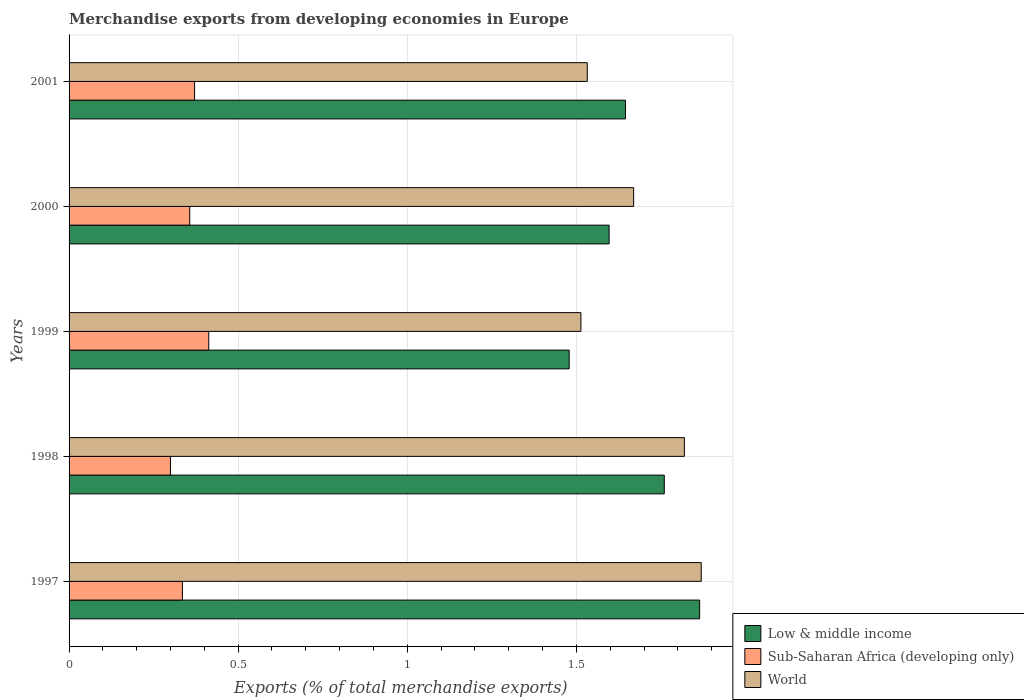Are the number of bars on each tick of the Y-axis equal?
Give a very brief answer. Yes. How many bars are there on the 3rd tick from the bottom?
Provide a short and direct response. 3. In how many cases, is the number of bars for a given year not equal to the number of legend labels?
Offer a terse response. 0. What is the percentage of total merchandise exports in Low & middle income in 1998?
Offer a very short reply. 1.76. Across all years, what is the maximum percentage of total merchandise exports in World?
Ensure brevity in your answer.  1.87. Across all years, what is the minimum percentage of total merchandise exports in Sub-Saharan Africa (developing only)?
Keep it short and to the point. 0.3. In which year was the percentage of total merchandise exports in World maximum?
Your answer should be very brief. 1997. What is the total percentage of total merchandise exports in Low & middle income in the graph?
Your answer should be compact. 8.35. What is the difference between the percentage of total merchandise exports in Sub-Saharan Africa (developing only) in 1998 and that in 1999?
Provide a short and direct response. -0.11. What is the difference between the percentage of total merchandise exports in World in 2000 and the percentage of total merchandise exports in Low & middle income in 2001?
Offer a terse response. 0.02. What is the average percentage of total merchandise exports in Sub-Saharan Africa (developing only) per year?
Offer a terse response. 0.36. In the year 2001, what is the difference between the percentage of total merchandise exports in Sub-Saharan Africa (developing only) and percentage of total merchandise exports in Low & middle income?
Keep it short and to the point. -1.27. What is the ratio of the percentage of total merchandise exports in Low & middle income in 1998 to that in 2000?
Ensure brevity in your answer.  1.1. What is the difference between the highest and the second highest percentage of total merchandise exports in World?
Keep it short and to the point. 0.05. What is the difference between the highest and the lowest percentage of total merchandise exports in Low & middle income?
Your answer should be compact. 0.39. Is the sum of the percentage of total merchandise exports in Sub-Saharan Africa (developing only) in 1998 and 1999 greater than the maximum percentage of total merchandise exports in Low & middle income across all years?
Your answer should be compact. No. What does the 2nd bar from the top in 2001 represents?
Offer a very short reply. Sub-Saharan Africa (developing only). Is it the case that in every year, the sum of the percentage of total merchandise exports in Sub-Saharan Africa (developing only) and percentage of total merchandise exports in World is greater than the percentage of total merchandise exports in Low & middle income?
Ensure brevity in your answer.  Yes. Are all the bars in the graph horizontal?
Provide a succinct answer. Yes. Are the values on the major ticks of X-axis written in scientific E-notation?
Your answer should be compact. No. What is the title of the graph?
Provide a succinct answer. Merchandise exports from developing economies in Europe. Does "Zambia" appear as one of the legend labels in the graph?
Ensure brevity in your answer.  No. What is the label or title of the X-axis?
Make the answer very short. Exports (% of total merchandise exports). What is the Exports (% of total merchandise exports) of Low & middle income in 1997?
Give a very brief answer. 1.86. What is the Exports (% of total merchandise exports) of Sub-Saharan Africa (developing only) in 1997?
Give a very brief answer. 0.34. What is the Exports (% of total merchandise exports) of World in 1997?
Keep it short and to the point. 1.87. What is the Exports (% of total merchandise exports) of Low & middle income in 1998?
Provide a succinct answer. 1.76. What is the Exports (% of total merchandise exports) in Sub-Saharan Africa (developing only) in 1998?
Your response must be concise. 0.3. What is the Exports (% of total merchandise exports) of World in 1998?
Provide a short and direct response. 1.82. What is the Exports (% of total merchandise exports) of Low & middle income in 1999?
Offer a terse response. 1.48. What is the Exports (% of total merchandise exports) in Sub-Saharan Africa (developing only) in 1999?
Provide a succinct answer. 0.41. What is the Exports (% of total merchandise exports) of World in 1999?
Give a very brief answer. 1.51. What is the Exports (% of total merchandise exports) in Low & middle income in 2000?
Provide a succinct answer. 1.6. What is the Exports (% of total merchandise exports) in Sub-Saharan Africa (developing only) in 2000?
Provide a succinct answer. 0.36. What is the Exports (% of total merchandise exports) in World in 2000?
Offer a very short reply. 1.67. What is the Exports (% of total merchandise exports) in Low & middle income in 2001?
Give a very brief answer. 1.65. What is the Exports (% of total merchandise exports) of Sub-Saharan Africa (developing only) in 2001?
Keep it short and to the point. 0.37. What is the Exports (% of total merchandise exports) in World in 2001?
Give a very brief answer. 1.53. Across all years, what is the maximum Exports (% of total merchandise exports) in Low & middle income?
Keep it short and to the point. 1.86. Across all years, what is the maximum Exports (% of total merchandise exports) of Sub-Saharan Africa (developing only)?
Your answer should be compact. 0.41. Across all years, what is the maximum Exports (% of total merchandise exports) of World?
Offer a very short reply. 1.87. Across all years, what is the minimum Exports (% of total merchandise exports) in Low & middle income?
Your answer should be compact. 1.48. Across all years, what is the minimum Exports (% of total merchandise exports) of Sub-Saharan Africa (developing only)?
Offer a very short reply. 0.3. Across all years, what is the minimum Exports (% of total merchandise exports) of World?
Offer a very short reply. 1.51. What is the total Exports (% of total merchandise exports) in Low & middle income in the graph?
Provide a short and direct response. 8.35. What is the total Exports (% of total merchandise exports) of Sub-Saharan Africa (developing only) in the graph?
Your response must be concise. 1.78. What is the total Exports (% of total merchandise exports) of World in the graph?
Ensure brevity in your answer.  8.4. What is the difference between the Exports (% of total merchandise exports) of Low & middle income in 1997 and that in 1998?
Provide a succinct answer. 0.1. What is the difference between the Exports (% of total merchandise exports) in Sub-Saharan Africa (developing only) in 1997 and that in 1998?
Your response must be concise. 0.04. What is the difference between the Exports (% of total merchandise exports) in World in 1997 and that in 1998?
Provide a succinct answer. 0.05. What is the difference between the Exports (% of total merchandise exports) in Low & middle income in 1997 and that in 1999?
Offer a very short reply. 0.39. What is the difference between the Exports (% of total merchandise exports) of Sub-Saharan Africa (developing only) in 1997 and that in 1999?
Provide a short and direct response. -0.08. What is the difference between the Exports (% of total merchandise exports) in World in 1997 and that in 1999?
Your answer should be very brief. 0.36. What is the difference between the Exports (% of total merchandise exports) of Low & middle income in 1997 and that in 2000?
Offer a very short reply. 0.27. What is the difference between the Exports (% of total merchandise exports) in Sub-Saharan Africa (developing only) in 1997 and that in 2000?
Your answer should be very brief. -0.02. What is the difference between the Exports (% of total merchandise exports) of World in 1997 and that in 2000?
Make the answer very short. 0.2. What is the difference between the Exports (% of total merchandise exports) in Low & middle income in 1997 and that in 2001?
Ensure brevity in your answer.  0.22. What is the difference between the Exports (% of total merchandise exports) in Sub-Saharan Africa (developing only) in 1997 and that in 2001?
Your response must be concise. -0.04. What is the difference between the Exports (% of total merchandise exports) in World in 1997 and that in 2001?
Make the answer very short. 0.34. What is the difference between the Exports (% of total merchandise exports) of Low & middle income in 1998 and that in 1999?
Offer a very short reply. 0.28. What is the difference between the Exports (% of total merchandise exports) of Sub-Saharan Africa (developing only) in 1998 and that in 1999?
Ensure brevity in your answer.  -0.11. What is the difference between the Exports (% of total merchandise exports) of World in 1998 and that in 1999?
Your response must be concise. 0.31. What is the difference between the Exports (% of total merchandise exports) of Low & middle income in 1998 and that in 2000?
Your answer should be very brief. 0.16. What is the difference between the Exports (% of total merchandise exports) of Sub-Saharan Africa (developing only) in 1998 and that in 2000?
Your answer should be very brief. -0.06. What is the difference between the Exports (% of total merchandise exports) of World in 1998 and that in 2000?
Provide a succinct answer. 0.15. What is the difference between the Exports (% of total merchandise exports) in Low & middle income in 1998 and that in 2001?
Offer a terse response. 0.11. What is the difference between the Exports (% of total merchandise exports) of Sub-Saharan Africa (developing only) in 1998 and that in 2001?
Give a very brief answer. -0.07. What is the difference between the Exports (% of total merchandise exports) of World in 1998 and that in 2001?
Provide a short and direct response. 0.29. What is the difference between the Exports (% of total merchandise exports) in Low & middle income in 1999 and that in 2000?
Your answer should be very brief. -0.12. What is the difference between the Exports (% of total merchandise exports) in Sub-Saharan Africa (developing only) in 1999 and that in 2000?
Provide a short and direct response. 0.06. What is the difference between the Exports (% of total merchandise exports) of World in 1999 and that in 2000?
Provide a succinct answer. -0.16. What is the difference between the Exports (% of total merchandise exports) in Low & middle income in 1999 and that in 2001?
Keep it short and to the point. -0.17. What is the difference between the Exports (% of total merchandise exports) in Sub-Saharan Africa (developing only) in 1999 and that in 2001?
Offer a very short reply. 0.04. What is the difference between the Exports (% of total merchandise exports) of World in 1999 and that in 2001?
Your answer should be very brief. -0.02. What is the difference between the Exports (% of total merchandise exports) in Low & middle income in 2000 and that in 2001?
Give a very brief answer. -0.05. What is the difference between the Exports (% of total merchandise exports) of Sub-Saharan Africa (developing only) in 2000 and that in 2001?
Your answer should be compact. -0.01. What is the difference between the Exports (% of total merchandise exports) of World in 2000 and that in 2001?
Ensure brevity in your answer.  0.14. What is the difference between the Exports (% of total merchandise exports) in Low & middle income in 1997 and the Exports (% of total merchandise exports) in Sub-Saharan Africa (developing only) in 1998?
Offer a very short reply. 1.56. What is the difference between the Exports (% of total merchandise exports) in Low & middle income in 1997 and the Exports (% of total merchandise exports) in World in 1998?
Ensure brevity in your answer.  0.05. What is the difference between the Exports (% of total merchandise exports) of Sub-Saharan Africa (developing only) in 1997 and the Exports (% of total merchandise exports) of World in 1998?
Keep it short and to the point. -1.48. What is the difference between the Exports (% of total merchandise exports) in Low & middle income in 1997 and the Exports (% of total merchandise exports) in Sub-Saharan Africa (developing only) in 1999?
Offer a very short reply. 1.45. What is the difference between the Exports (% of total merchandise exports) of Low & middle income in 1997 and the Exports (% of total merchandise exports) of World in 1999?
Give a very brief answer. 0.35. What is the difference between the Exports (% of total merchandise exports) of Sub-Saharan Africa (developing only) in 1997 and the Exports (% of total merchandise exports) of World in 1999?
Give a very brief answer. -1.18. What is the difference between the Exports (% of total merchandise exports) of Low & middle income in 1997 and the Exports (% of total merchandise exports) of Sub-Saharan Africa (developing only) in 2000?
Give a very brief answer. 1.51. What is the difference between the Exports (% of total merchandise exports) in Low & middle income in 1997 and the Exports (% of total merchandise exports) in World in 2000?
Give a very brief answer. 0.2. What is the difference between the Exports (% of total merchandise exports) in Sub-Saharan Africa (developing only) in 1997 and the Exports (% of total merchandise exports) in World in 2000?
Keep it short and to the point. -1.33. What is the difference between the Exports (% of total merchandise exports) in Low & middle income in 1997 and the Exports (% of total merchandise exports) in Sub-Saharan Africa (developing only) in 2001?
Your answer should be very brief. 1.49. What is the difference between the Exports (% of total merchandise exports) of Low & middle income in 1997 and the Exports (% of total merchandise exports) of World in 2001?
Give a very brief answer. 0.33. What is the difference between the Exports (% of total merchandise exports) in Sub-Saharan Africa (developing only) in 1997 and the Exports (% of total merchandise exports) in World in 2001?
Provide a succinct answer. -1.2. What is the difference between the Exports (% of total merchandise exports) in Low & middle income in 1998 and the Exports (% of total merchandise exports) in Sub-Saharan Africa (developing only) in 1999?
Offer a terse response. 1.35. What is the difference between the Exports (% of total merchandise exports) in Low & middle income in 1998 and the Exports (% of total merchandise exports) in World in 1999?
Your response must be concise. 0.25. What is the difference between the Exports (% of total merchandise exports) in Sub-Saharan Africa (developing only) in 1998 and the Exports (% of total merchandise exports) in World in 1999?
Provide a succinct answer. -1.21. What is the difference between the Exports (% of total merchandise exports) in Low & middle income in 1998 and the Exports (% of total merchandise exports) in Sub-Saharan Africa (developing only) in 2000?
Your answer should be compact. 1.4. What is the difference between the Exports (% of total merchandise exports) of Low & middle income in 1998 and the Exports (% of total merchandise exports) of World in 2000?
Give a very brief answer. 0.09. What is the difference between the Exports (% of total merchandise exports) of Sub-Saharan Africa (developing only) in 1998 and the Exports (% of total merchandise exports) of World in 2000?
Make the answer very short. -1.37. What is the difference between the Exports (% of total merchandise exports) in Low & middle income in 1998 and the Exports (% of total merchandise exports) in Sub-Saharan Africa (developing only) in 2001?
Keep it short and to the point. 1.39. What is the difference between the Exports (% of total merchandise exports) of Low & middle income in 1998 and the Exports (% of total merchandise exports) of World in 2001?
Provide a succinct answer. 0.23. What is the difference between the Exports (% of total merchandise exports) in Sub-Saharan Africa (developing only) in 1998 and the Exports (% of total merchandise exports) in World in 2001?
Offer a terse response. -1.23. What is the difference between the Exports (% of total merchandise exports) in Low & middle income in 1999 and the Exports (% of total merchandise exports) in Sub-Saharan Africa (developing only) in 2000?
Give a very brief answer. 1.12. What is the difference between the Exports (% of total merchandise exports) of Low & middle income in 1999 and the Exports (% of total merchandise exports) of World in 2000?
Offer a very short reply. -0.19. What is the difference between the Exports (% of total merchandise exports) of Sub-Saharan Africa (developing only) in 1999 and the Exports (% of total merchandise exports) of World in 2000?
Your answer should be very brief. -1.26. What is the difference between the Exports (% of total merchandise exports) in Low & middle income in 1999 and the Exports (% of total merchandise exports) in Sub-Saharan Africa (developing only) in 2001?
Ensure brevity in your answer.  1.11. What is the difference between the Exports (% of total merchandise exports) of Low & middle income in 1999 and the Exports (% of total merchandise exports) of World in 2001?
Provide a short and direct response. -0.05. What is the difference between the Exports (% of total merchandise exports) of Sub-Saharan Africa (developing only) in 1999 and the Exports (% of total merchandise exports) of World in 2001?
Offer a very short reply. -1.12. What is the difference between the Exports (% of total merchandise exports) of Low & middle income in 2000 and the Exports (% of total merchandise exports) of Sub-Saharan Africa (developing only) in 2001?
Ensure brevity in your answer.  1.23. What is the difference between the Exports (% of total merchandise exports) of Low & middle income in 2000 and the Exports (% of total merchandise exports) of World in 2001?
Provide a succinct answer. 0.06. What is the difference between the Exports (% of total merchandise exports) of Sub-Saharan Africa (developing only) in 2000 and the Exports (% of total merchandise exports) of World in 2001?
Provide a short and direct response. -1.18. What is the average Exports (% of total merchandise exports) in Low & middle income per year?
Your answer should be very brief. 1.67. What is the average Exports (% of total merchandise exports) of Sub-Saharan Africa (developing only) per year?
Ensure brevity in your answer.  0.36. What is the average Exports (% of total merchandise exports) in World per year?
Your response must be concise. 1.68. In the year 1997, what is the difference between the Exports (% of total merchandise exports) of Low & middle income and Exports (% of total merchandise exports) of Sub-Saharan Africa (developing only)?
Your response must be concise. 1.53. In the year 1997, what is the difference between the Exports (% of total merchandise exports) in Low & middle income and Exports (% of total merchandise exports) in World?
Provide a succinct answer. -0. In the year 1997, what is the difference between the Exports (% of total merchandise exports) of Sub-Saharan Africa (developing only) and Exports (% of total merchandise exports) of World?
Make the answer very short. -1.53. In the year 1998, what is the difference between the Exports (% of total merchandise exports) of Low & middle income and Exports (% of total merchandise exports) of Sub-Saharan Africa (developing only)?
Give a very brief answer. 1.46. In the year 1998, what is the difference between the Exports (% of total merchandise exports) in Low & middle income and Exports (% of total merchandise exports) in World?
Your answer should be very brief. -0.06. In the year 1998, what is the difference between the Exports (% of total merchandise exports) in Sub-Saharan Africa (developing only) and Exports (% of total merchandise exports) in World?
Your response must be concise. -1.52. In the year 1999, what is the difference between the Exports (% of total merchandise exports) in Low & middle income and Exports (% of total merchandise exports) in Sub-Saharan Africa (developing only)?
Offer a terse response. 1.07. In the year 1999, what is the difference between the Exports (% of total merchandise exports) in Low & middle income and Exports (% of total merchandise exports) in World?
Offer a very short reply. -0.03. In the year 1999, what is the difference between the Exports (% of total merchandise exports) of Sub-Saharan Africa (developing only) and Exports (% of total merchandise exports) of World?
Keep it short and to the point. -1.1. In the year 2000, what is the difference between the Exports (% of total merchandise exports) in Low & middle income and Exports (% of total merchandise exports) in Sub-Saharan Africa (developing only)?
Your response must be concise. 1.24. In the year 2000, what is the difference between the Exports (% of total merchandise exports) of Low & middle income and Exports (% of total merchandise exports) of World?
Offer a very short reply. -0.07. In the year 2000, what is the difference between the Exports (% of total merchandise exports) in Sub-Saharan Africa (developing only) and Exports (% of total merchandise exports) in World?
Offer a very short reply. -1.31. In the year 2001, what is the difference between the Exports (% of total merchandise exports) of Low & middle income and Exports (% of total merchandise exports) of Sub-Saharan Africa (developing only)?
Offer a terse response. 1.27. In the year 2001, what is the difference between the Exports (% of total merchandise exports) of Low & middle income and Exports (% of total merchandise exports) of World?
Offer a terse response. 0.11. In the year 2001, what is the difference between the Exports (% of total merchandise exports) of Sub-Saharan Africa (developing only) and Exports (% of total merchandise exports) of World?
Offer a terse response. -1.16. What is the ratio of the Exports (% of total merchandise exports) of Low & middle income in 1997 to that in 1998?
Offer a very short reply. 1.06. What is the ratio of the Exports (% of total merchandise exports) of Sub-Saharan Africa (developing only) in 1997 to that in 1998?
Your answer should be very brief. 1.12. What is the ratio of the Exports (% of total merchandise exports) of World in 1997 to that in 1998?
Offer a very short reply. 1.03. What is the ratio of the Exports (% of total merchandise exports) of Low & middle income in 1997 to that in 1999?
Offer a very short reply. 1.26. What is the ratio of the Exports (% of total merchandise exports) of Sub-Saharan Africa (developing only) in 1997 to that in 1999?
Provide a succinct answer. 0.81. What is the ratio of the Exports (% of total merchandise exports) of World in 1997 to that in 1999?
Offer a very short reply. 1.24. What is the ratio of the Exports (% of total merchandise exports) of Low & middle income in 1997 to that in 2000?
Make the answer very short. 1.17. What is the ratio of the Exports (% of total merchandise exports) of Sub-Saharan Africa (developing only) in 1997 to that in 2000?
Your answer should be very brief. 0.94. What is the ratio of the Exports (% of total merchandise exports) of World in 1997 to that in 2000?
Give a very brief answer. 1.12. What is the ratio of the Exports (% of total merchandise exports) in Low & middle income in 1997 to that in 2001?
Your answer should be very brief. 1.13. What is the ratio of the Exports (% of total merchandise exports) in Sub-Saharan Africa (developing only) in 1997 to that in 2001?
Your answer should be compact. 0.9. What is the ratio of the Exports (% of total merchandise exports) of World in 1997 to that in 2001?
Offer a very short reply. 1.22. What is the ratio of the Exports (% of total merchandise exports) in Low & middle income in 1998 to that in 1999?
Make the answer very short. 1.19. What is the ratio of the Exports (% of total merchandise exports) in Sub-Saharan Africa (developing only) in 1998 to that in 1999?
Make the answer very short. 0.73. What is the ratio of the Exports (% of total merchandise exports) of World in 1998 to that in 1999?
Your answer should be compact. 1.2. What is the ratio of the Exports (% of total merchandise exports) of Low & middle income in 1998 to that in 2000?
Your response must be concise. 1.1. What is the ratio of the Exports (% of total merchandise exports) of Sub-Saharan Africa (developing only) in 1998 to that in 2000?
Give a very brief answer. 0.84. What is the ratio of the Exports (% of total merchandise exports) in World in 1998 to that in 2000?
Your answer should be compact. 1.09. What is the ratio of the Exports (% of total merchandise exports) in Low & middle income in 1998 to that in 2001?
Provide a succinct answer. 1.07. What is the ratio of the Exports (% of total merchandise exports) of Sub-Saharan Africa (developing only) in 1998 to that in 2001?
Your answer should be very brief. 0.81. What is the ratio of the Exports (% of total merchandise exports) in World in 1998 to that in 2001?
Ensure brevity in your answer.  1.19. What is the ratio of the Exports (% of total merchandise exports) of Low & middle income in 1999 to that in 2000?
Your answer should be very brief. 0.93. What is the ratio of the Exports (% of total merchandise exports) of Sub-Saharan Africa (developing only) in 1999 to that in 2000?
Offer a very short reply. 1.16. What is the ratio of the Exports (% of total merchandise exports) of World in 1999 to that in 2000?
Offer a terse response. 0.91. What is the ratio of the Exports (% of total merchandise exports) in Low & middle income in 1999 to that in 2001?
Ensure brevity in your answer.  0.9. What is the ratio of the Exports (% of total merchandise exports) of Sub-Saharan Africa (developing only) in 1999 to that in 2001?
Provide a succinct answer. 1.11. What is the ratio of the Exports (% of total merchandise exports) in Low & middle income in 2000 to that in 2001?
Your answer should be compact. 0.97. What is the ratio of the Exports (% of total merchandise exports) of Sub-Saharan Africa (developing only) in 2000 to that in 2001?
Provide a succinct answer. 0.96. What is the ratio of the Exports (% of total merchandise exports) in World in 2000 to that in 2001?
Ensure brevity in your answer.  1.09. What is the difference between the highest and the second highest Exports (% of total merchandise exports) of Low & middle income?
Keep it short and to the point. 0.1. What is the difference between the highest and the second highest Exports (% of total merchandise exports) of Sub-Saharan Africa (developing only)?
Your response must be concise. 0.04. What is the difference between the highest and the second highest Exports (% of total merchandise exports) of World?
Offer a very short reply. 0.05. What is the difference between the highest and the lowest Exports (% of total merchandise exports) of Low & middle income?
Offer a very short reply. 0.39. What is the difference between the highest and the lowest Exports (% of total merchandise exports) of Sub-Saharan Africa (developing only)?
Your answer should be very brief. 0.11. What is the difference between the highest and the lowest Exports (% of total merchandise exports) of World?
Your response must be concise. 0.36. 